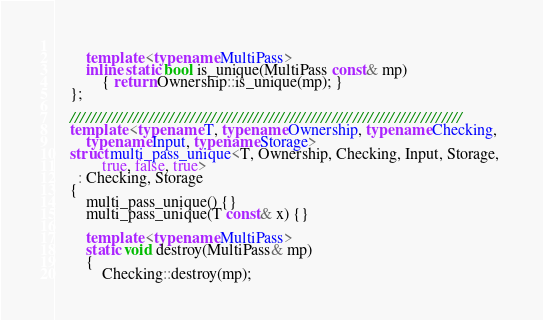<code> <loc_0><loc_0><loc_500><loc_500><_C++_>        
        template <typename MultiPass>
        inline static bool is_unique(MultiPass const& mp)
            { return Ownership::is_unique(mp); }
    };

    ///////////////////////////////////////////////////////////////////////////
    template <typename T, typename Ownership, typename Checking, 
        typename Input, typename Storage>
    struct multi_pass_unique<T, Ownership, Checking, Input, Storage, 
            true, false, true>
      : Checking, Storage
    {
        multi_pass_unique() {}
        multi_pass_unique(T const& x) {}

        template <typename MultiPass>
        static void destroy(MultiPass& mp)
        {
            Checking::destroy(mp);</code> 